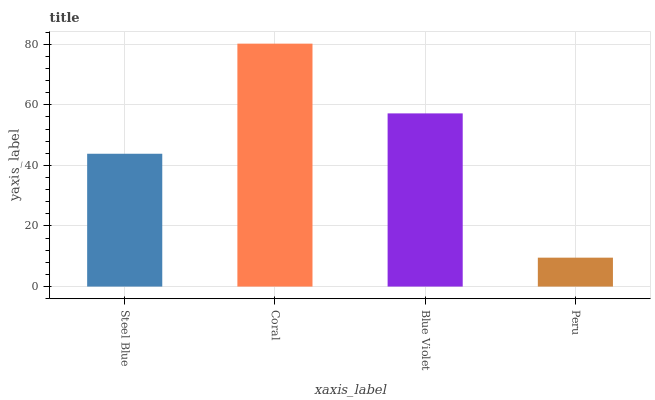Is Peru the minimum?
Answer yes or no. Yes. Is Coral the maximum?
Answer yes or no. Yes. Is Blue Violet the minimum?
Answer yes or no. No. Is Blue Violet the maximum?
Answer yes or no. No. Is Coral greater than Blue Violet?
Answer yes or no. Yes. Is Blue Violet less than Coral?
Answer yes or no. Yes. Is Blue Violet greater than Coral?
Answer yes or no. No. Is Coral less than Blue Violet?
Answer yes or no. No. Is Blue Violet the high median?
Answer yes or no. Yes. Is Steel Blue the low median?
Answer yes or no. Yes. Is Peru the high median?
Answer yes or no. No. Is Blue Violet the low median?
Answer yes or no. No. 